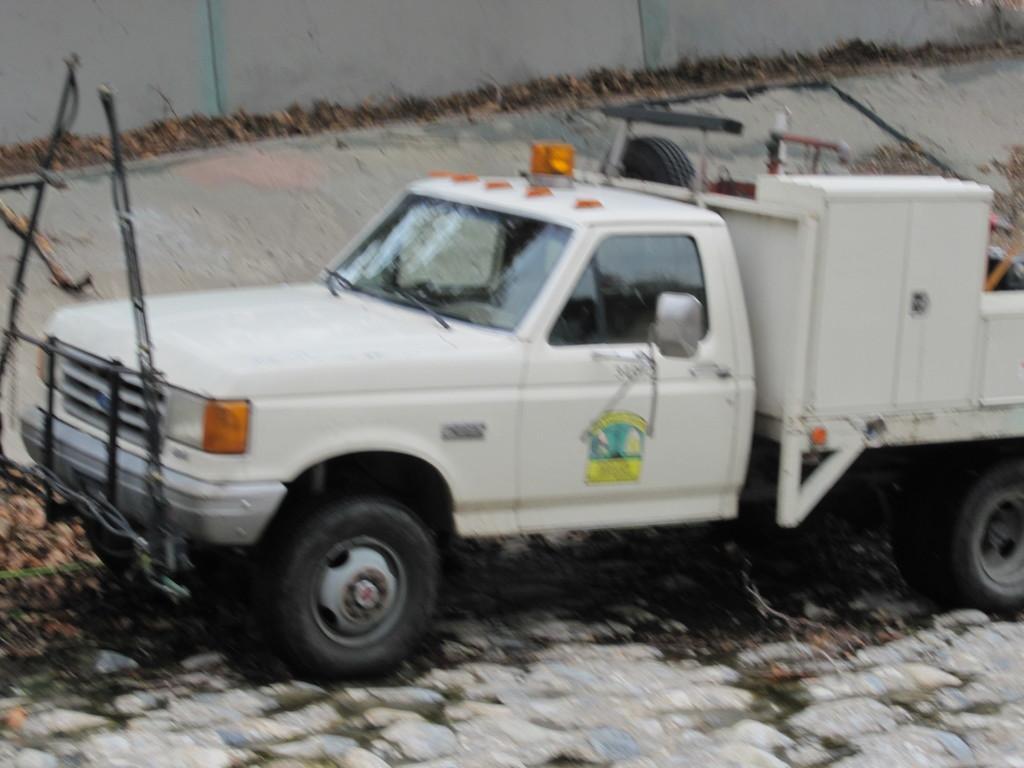Could you give a brief overview of what you see in this image? In this image, we can see a vehicle. There is a wall at the top of the image. There is an object on the left side of the image. 